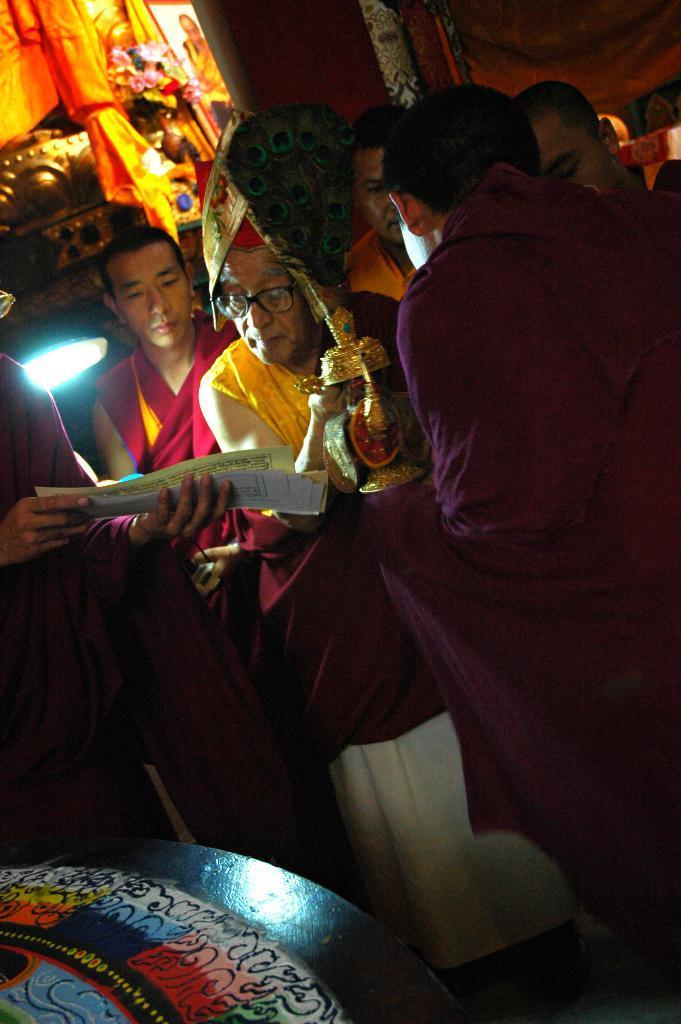In one or two sentences, can you explain what this image depicts? In this image, there are a few people. We can see the wall and some cloth. We can also see some object at the bottom. 